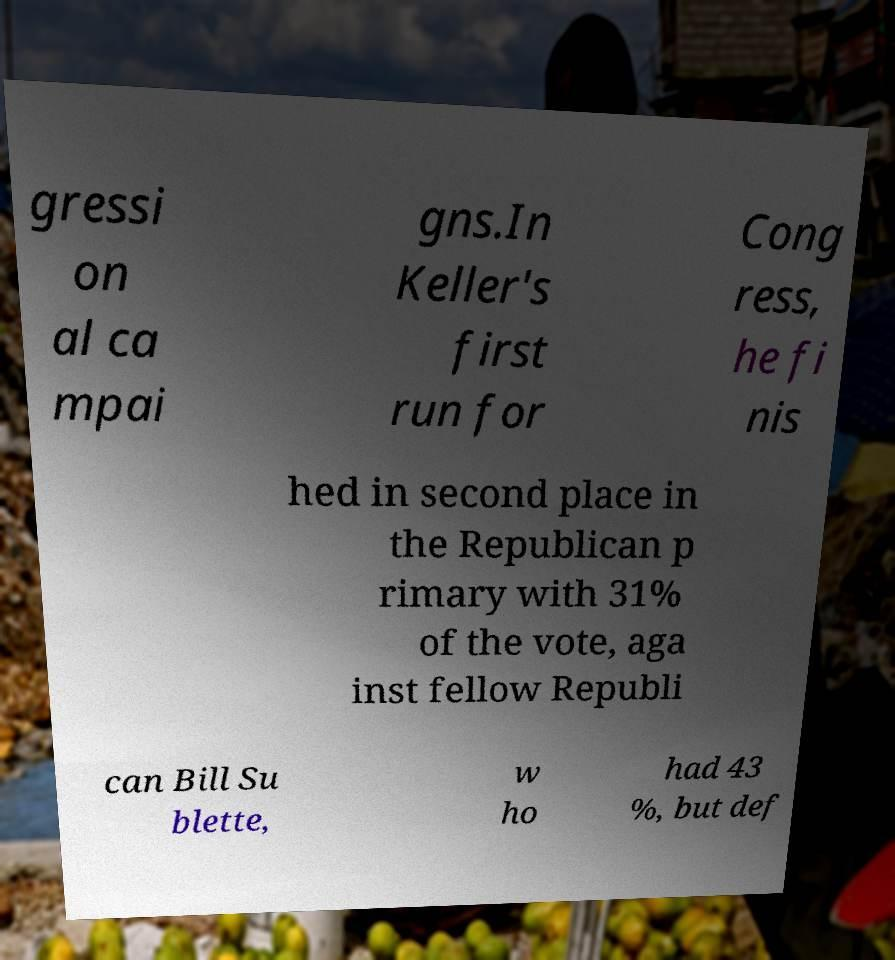Please identify and transcribe the text found in this image. gressi on al ca mpai gns.In Keller's first run for Cong ress, he fi nis hed in second place in the Republican p rimary with 31% of the vote, aga inst fellow Republi can Bill Su blette, w ho had 43 %, but def 